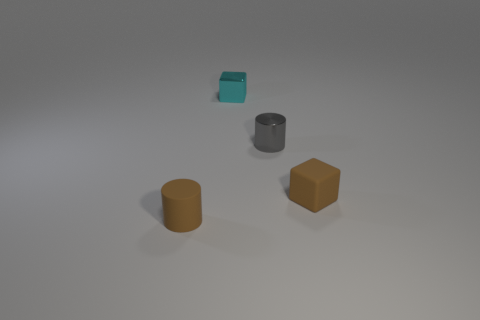Add 2 tiny brown rubber things. How many objects exist? 6 Subtract all small gray cylinders. Subtract all brown rubber cylinders. How many objects are left? 2 Add 3 brown rubber objects. How many brown rubber objects are left? 5 Add 2 matte things. How many matte things exist? 4 Subtract 0 cyan cylinders. How many objects are left? 4 